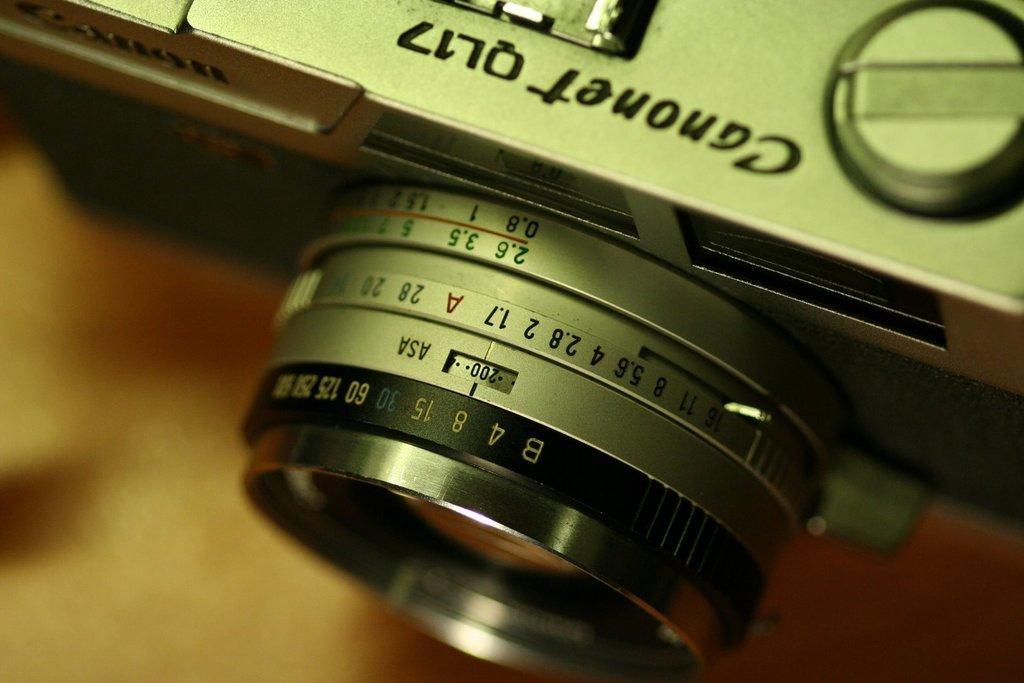Could you give a brief overview of what you see in this image? In this image we can see the lens of a camera. 